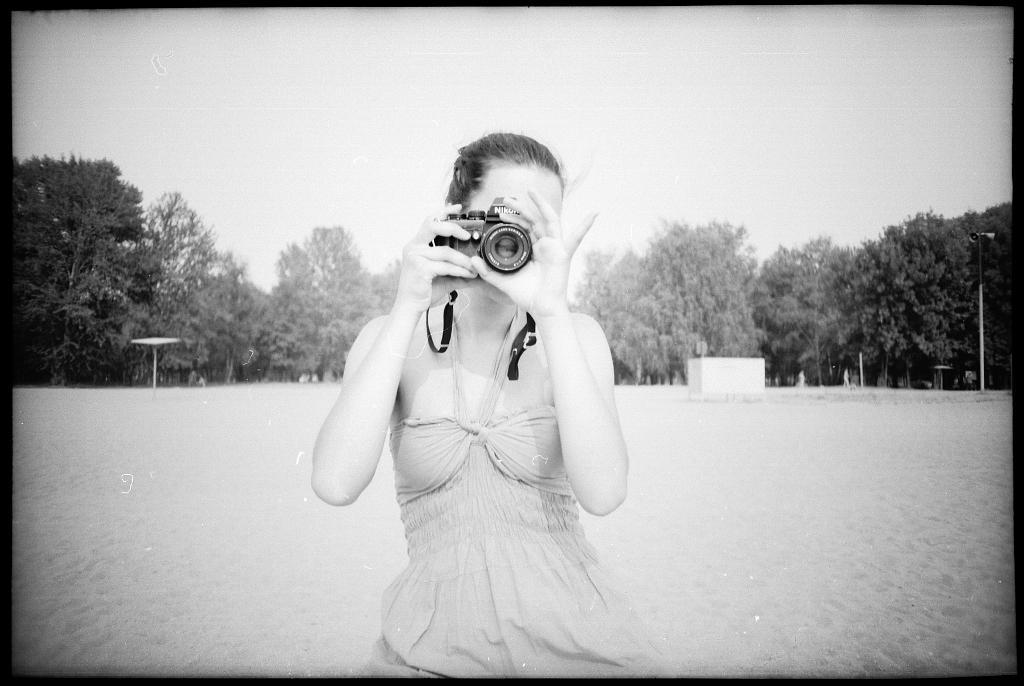In one or two sentences, can you explain what this image depicts? In this picture we can see a woman holding camera with her hand and taking picture and in the background we can see trees, pole, box, sky. 